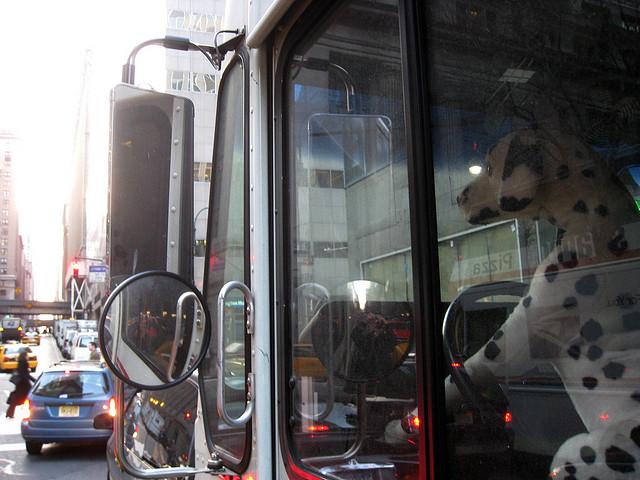Would you trust this driver to really drive this vehicle?
Quick response, please. No. Would a German Shepherd be just as appropriate as the breed shown?
Quick response, please. No. Is there a dog in the image?
Answer briefly. Yes. 